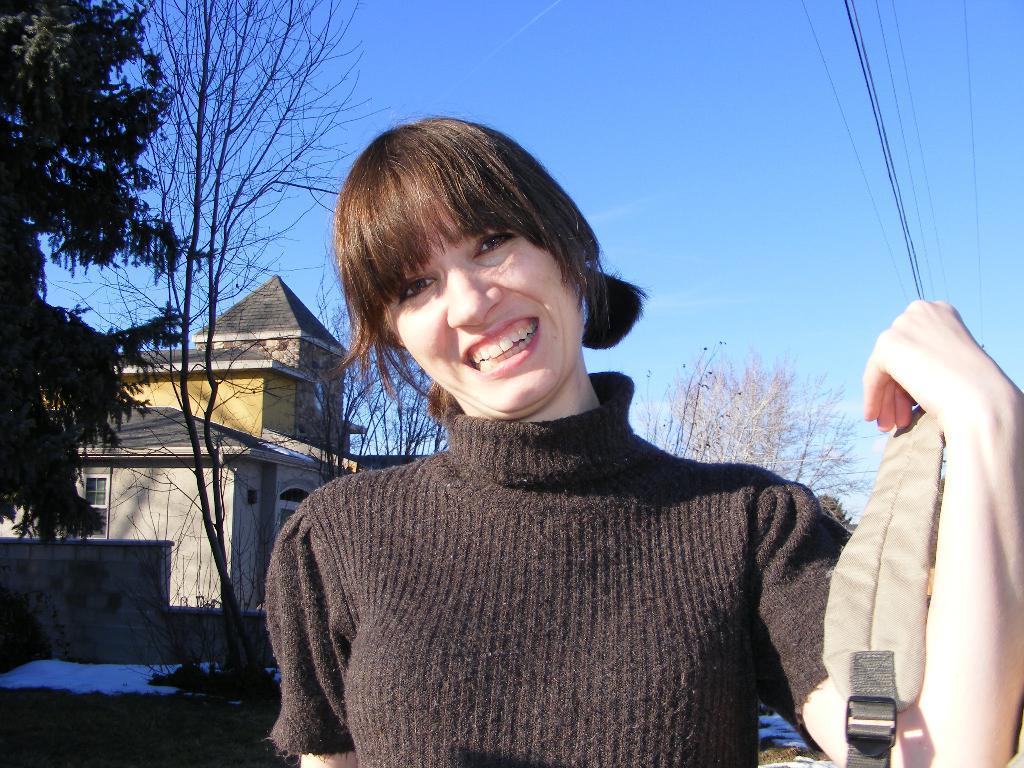Could you give a brief overview of what you see in this image? In the foreground of this picture, there is a woman in back dress holding a bag in her hand, In the background, there are trees, house, cables and the sky. 